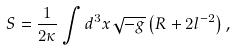<formula> <loc_0><loc_0><loc_500><loc_500>S = \frac { 1 } { 2 \kappa } \int { d ^ { 3 } x } \sqrt { - g } \left ( R + 2 l ^ { - 2 } \right ) ,</formula> 